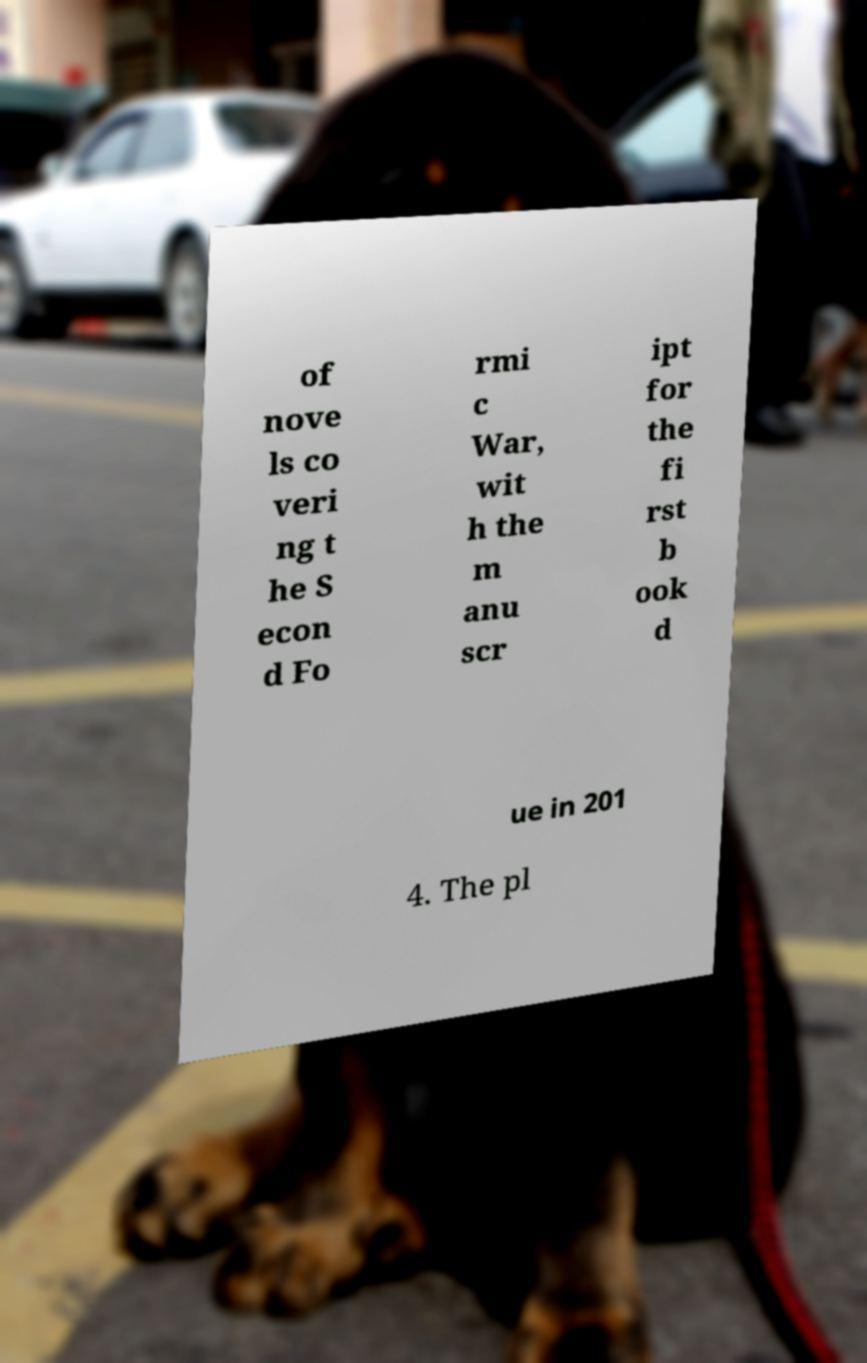Could you assist in decoding the text presented in this image and type it out clearly? of nove ls co veri ng t he S econ d Fo rmi c War, wit h the m anu scr ipt for the fi rst b ook d ue in 201 4. The pl 